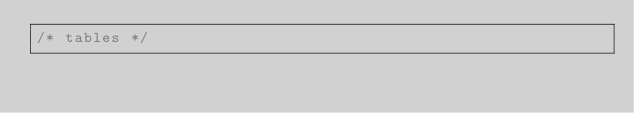<code> <loc_0><loc_0><loc_500><loc_500><_CSS_>/* tables */</code> 